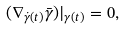<formula> <loc_0><loc_0><loc_500><loc_500>( \nabla _ { \dot { \gamma } ( t ) } \bar { \gamma } ) | _ { \gamma ( t ) } = 0 ,</formula> 